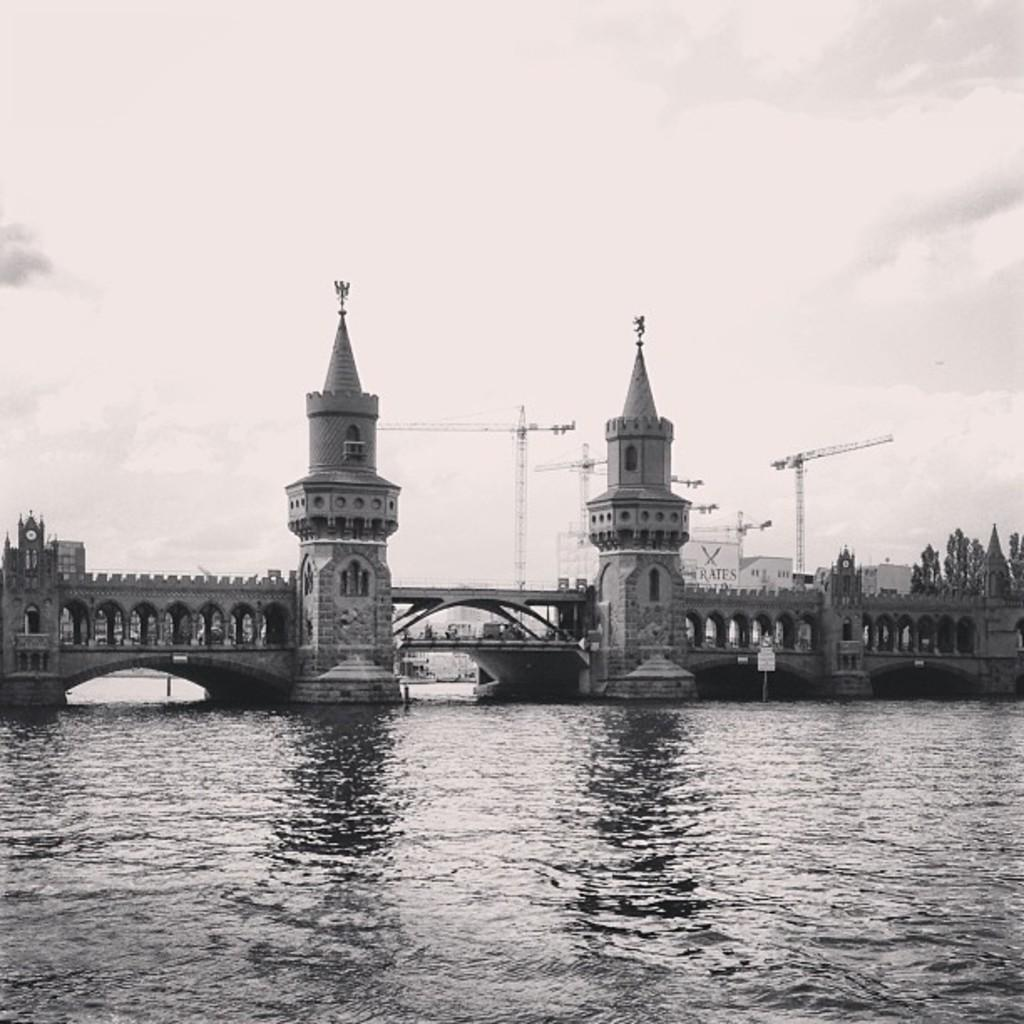What structure can be seen in the image? There is a bridge in the image. Can you describe the bridge's features? The bridge has walls and pillars. What is visible beneath the bridge? There is water visible at the bottom of the bridge. What type of vegetation can be seen in the image? There are trees in the image. What other structures are present in the image? There are towers in the image. How would you describe the sky in the image? The sky is visible in the background of the image, and it appears to be cloudy. How much sugar is dissolved in the water under the bridge? There is no information about sugar in the image, as it only features a bridge, water, trees, towers, and a cloudy sky. 